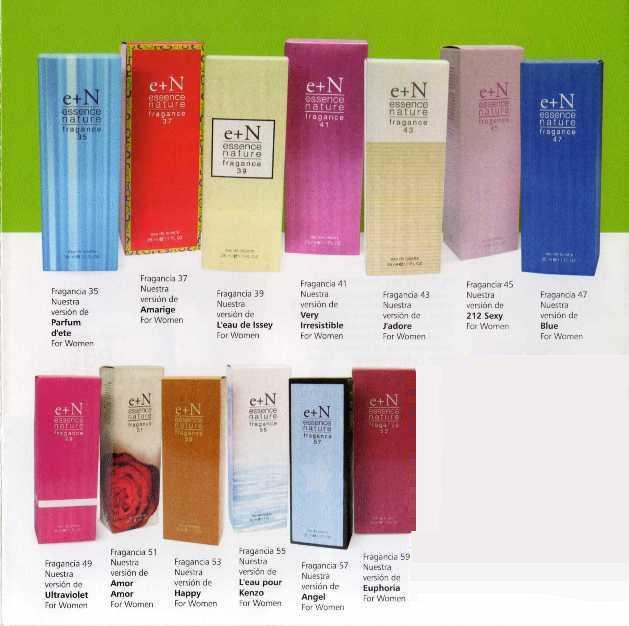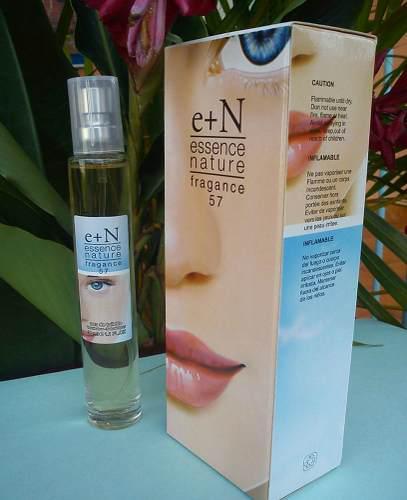The first image is the image on the left, the second image is the image on the right. Given the left and right images, does the statement "An image shows a single row of at least five upright boxes standing on a shiny surface." hold true? Answer yes or no. No. The first image is the image on the left, the second image is the image on the right. Evaluate the accuracy of this statement regarding the images: "The lone box of 'essence of nature' features half of a female face.". Is it true? Answer yes or no. Yes. 